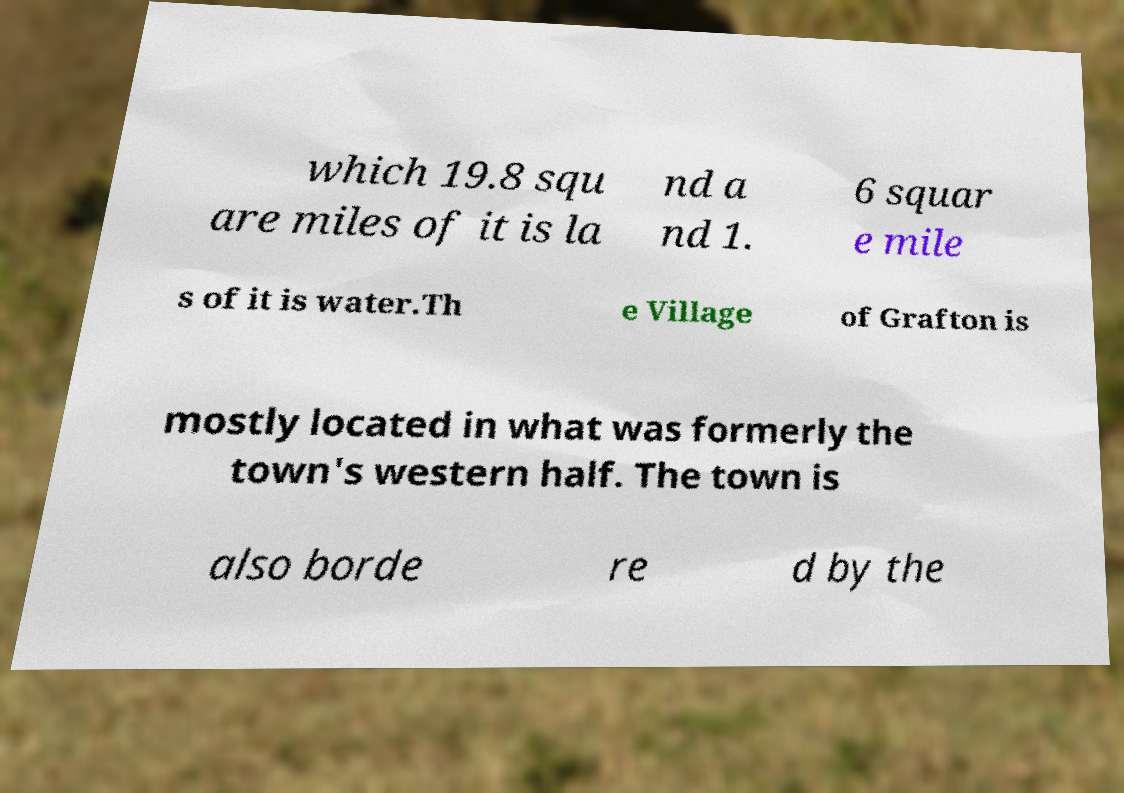There's text embedded in this image that I need extracted. Can you transcribe it verbatim? which 19.8 squ are miles of it is la nd a nd 1. 6 squar e mile s of it is water.Th e Village of Grafton is mostly located in what was formerly the town's western half. The town is also borde re d by the 